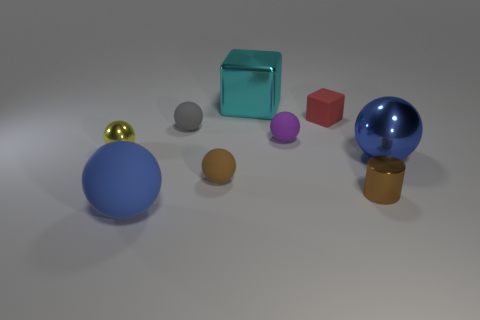Are there any gray cylinders that have the same size as the purple thing?
Your answer should be compact. No. What size is the metallic sphere that is in front of the yellow metallic object?
Provide a succinct answer. Large. There is a small sphere in front of the ball that is left of the ball in front of the brown rubber sphere; what is its color?
Your answer should be compact. Brown. The shiny thing that is to the left of the big thing that is behind the tiny red rubber block is what color?
Provide a succinct answer. Yellow. Is the number of cyan metallic cubes in front of the cyan object greater than the number of big metallic balls behind the tiny gray rubber thing?
Keep it short and to the point. No. Do the brown object that is on the left side of the small metallic cylinder and the tiny red block that is behind the tiny yellow ball have the same material?
Give a very brief answer. Yes. There is a small yellow ball; are there any small yellow metallic objects behind it?
Provide a succinct answer. No. What number of blue things are either small blocks or balls?
Keep it short and to the point. 2. Are the yellow object and the blue sphere on the right side of the big rubber sphere made of the same material?
Your answer should be compact. Yes. What size is the other metal object that is the same shape as the small yellow object?
Provide a succinct answer. Large. 